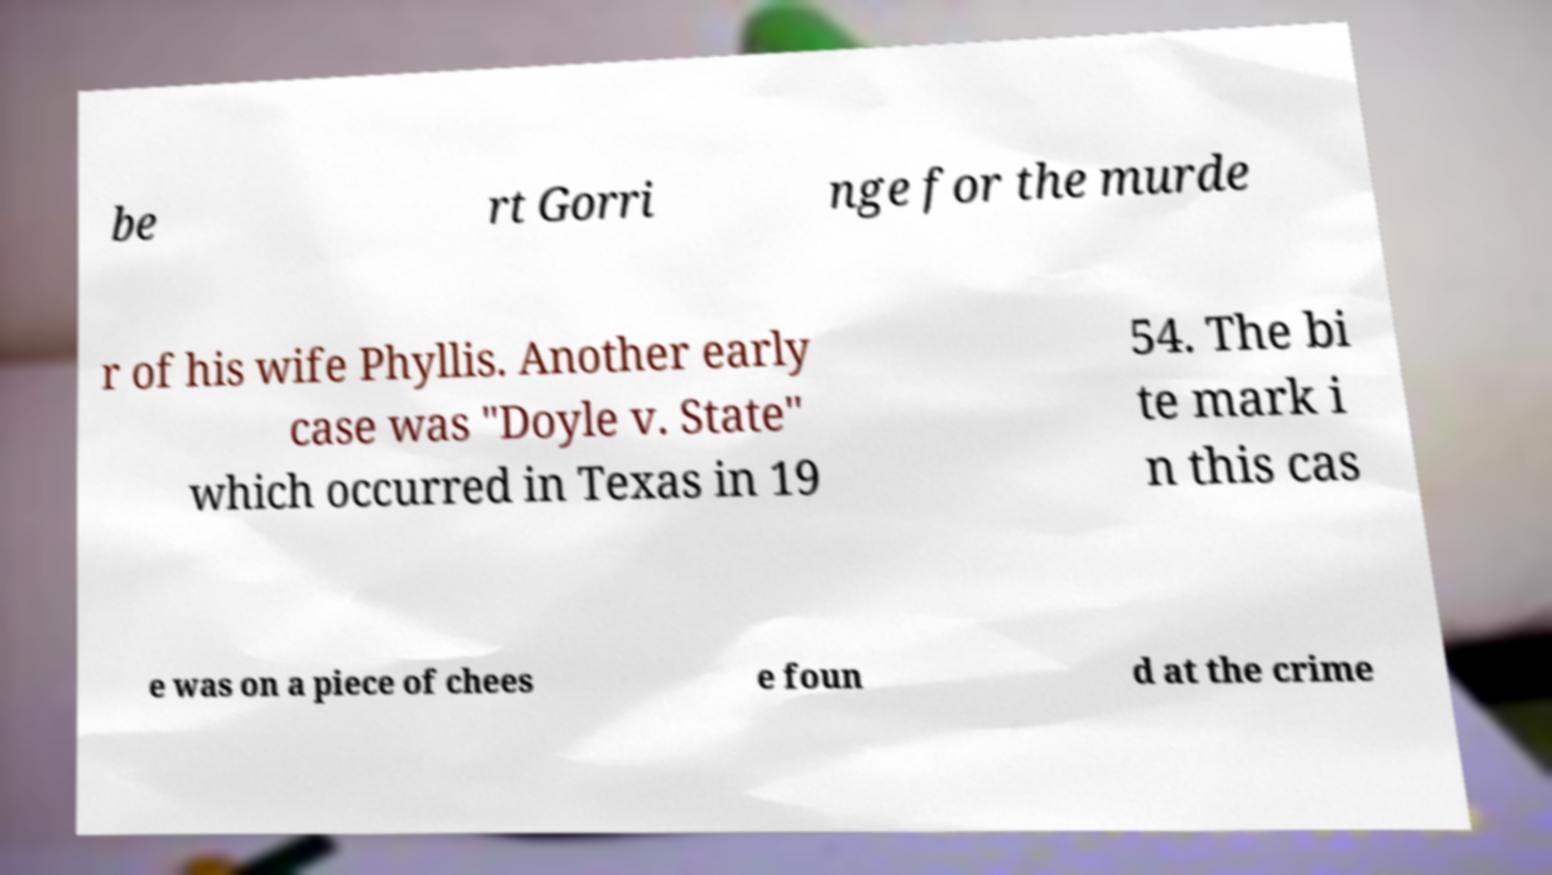Could you extract and type out the text from this image? be rt Gorri nge for the murde r of his wife Phyllis. Another early case was "Doyle v. State" which occurred in Texas in 19 54. The bi te mark i n this cas e was on a piece of chees e foun d at the crime 